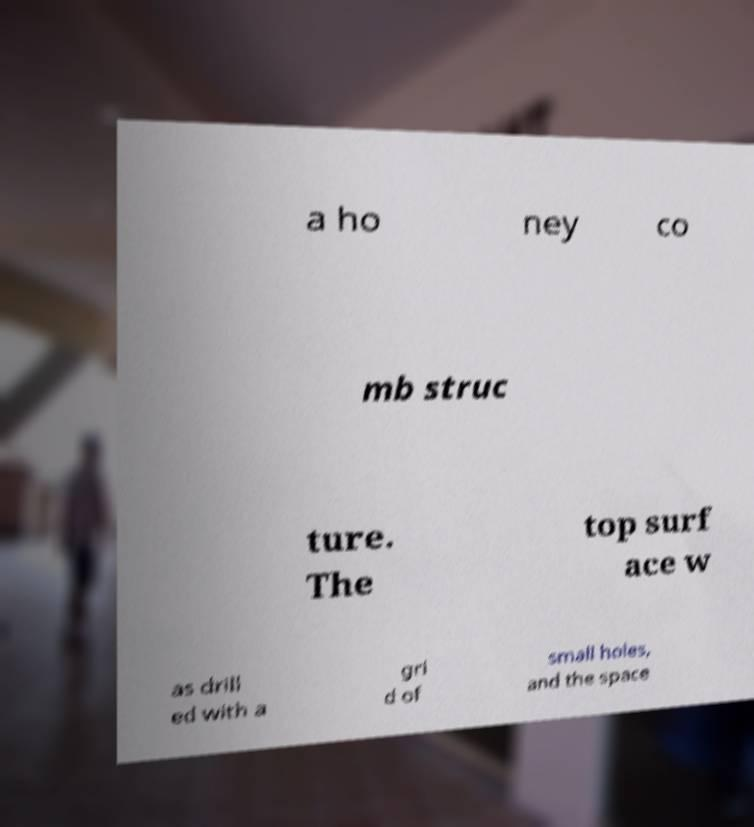Can you accurately transcribe the text from the provided image for me? a ho ney co mb struc ture. The top surf ace w as drill ed with a gri d of small holes, and the space 